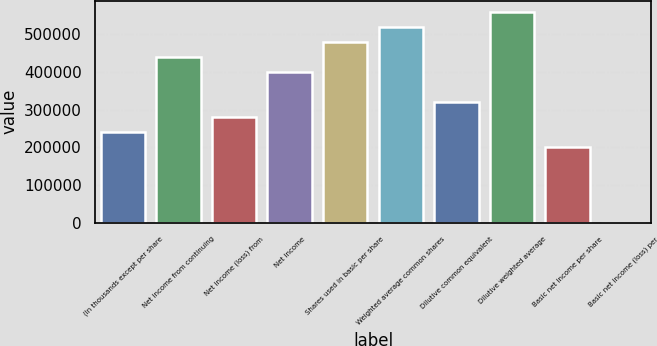Convert chart to OTSL. <chart><loc_0><loc_0><loc_500><loc_500><bar_chart><fcel>(In thousands except per share<fcel>Net income from continuing<fcel>Net income (loss) from<fcel>Net income<fcel>Shares used in basic per share<fcel>Weighted average common shares<fcel>Dilutive common equivalent<fcel>Dilutive weighted average<fcel>Basic net income per share<fcel>Basic net income (loss) per<nl><fcel>240097<fcel>440178<fcel>280113<fcel>400162<fcel>480194<fcel>520211<fcel>320130<fcel>560227<fcel>200081<fcel>0.02<nl></chart> 